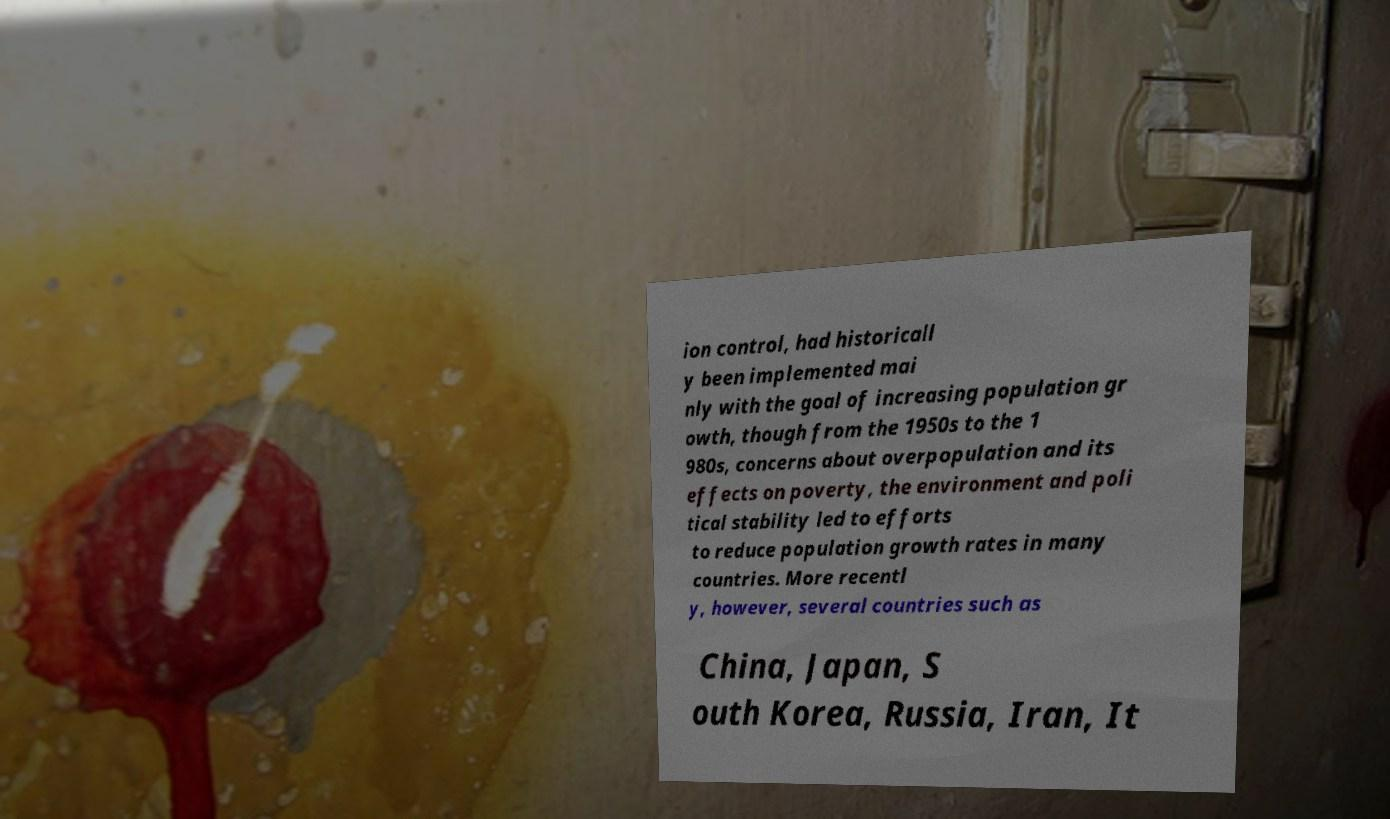There's text embedded in this image that I need extracted. Can you transcribe it verbatim? ion control, had historicall y been implemented mai nly with the goal of increasing population gr owth, though from the 1950s to the 1 980s, concerns about overpopulation and its effects on poverty, the environment and poli tical stability led to efforts to reduce population growth rates in many countries. More recentl y, however, several countries such as China, Japan, S outh Korea, Russia, Iran, It 